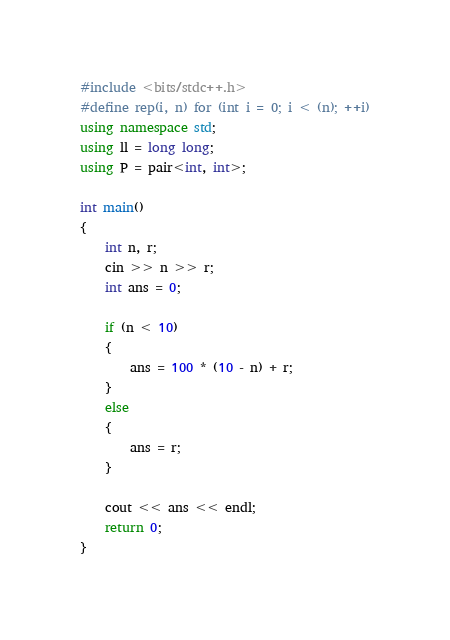<code> <loc_0><loc_0><loc_500><loc_500><_C++_>#include <bits/stdc++.h>
#define rep(i, n) for (int i = 0; i < (n); ++i)
using namespace std;
using ll = long long;
using P = pair<int, int>;

int main()
{
    int n, r;
    cin >> n >> r;
    int ans = 0;

    if (n < 10)
    {
        ans = 100 * (10 - n) + r;
    }
    else
    {
        ans = r;
    }

    cout << ans << endl;
    return 0;
}</code> 